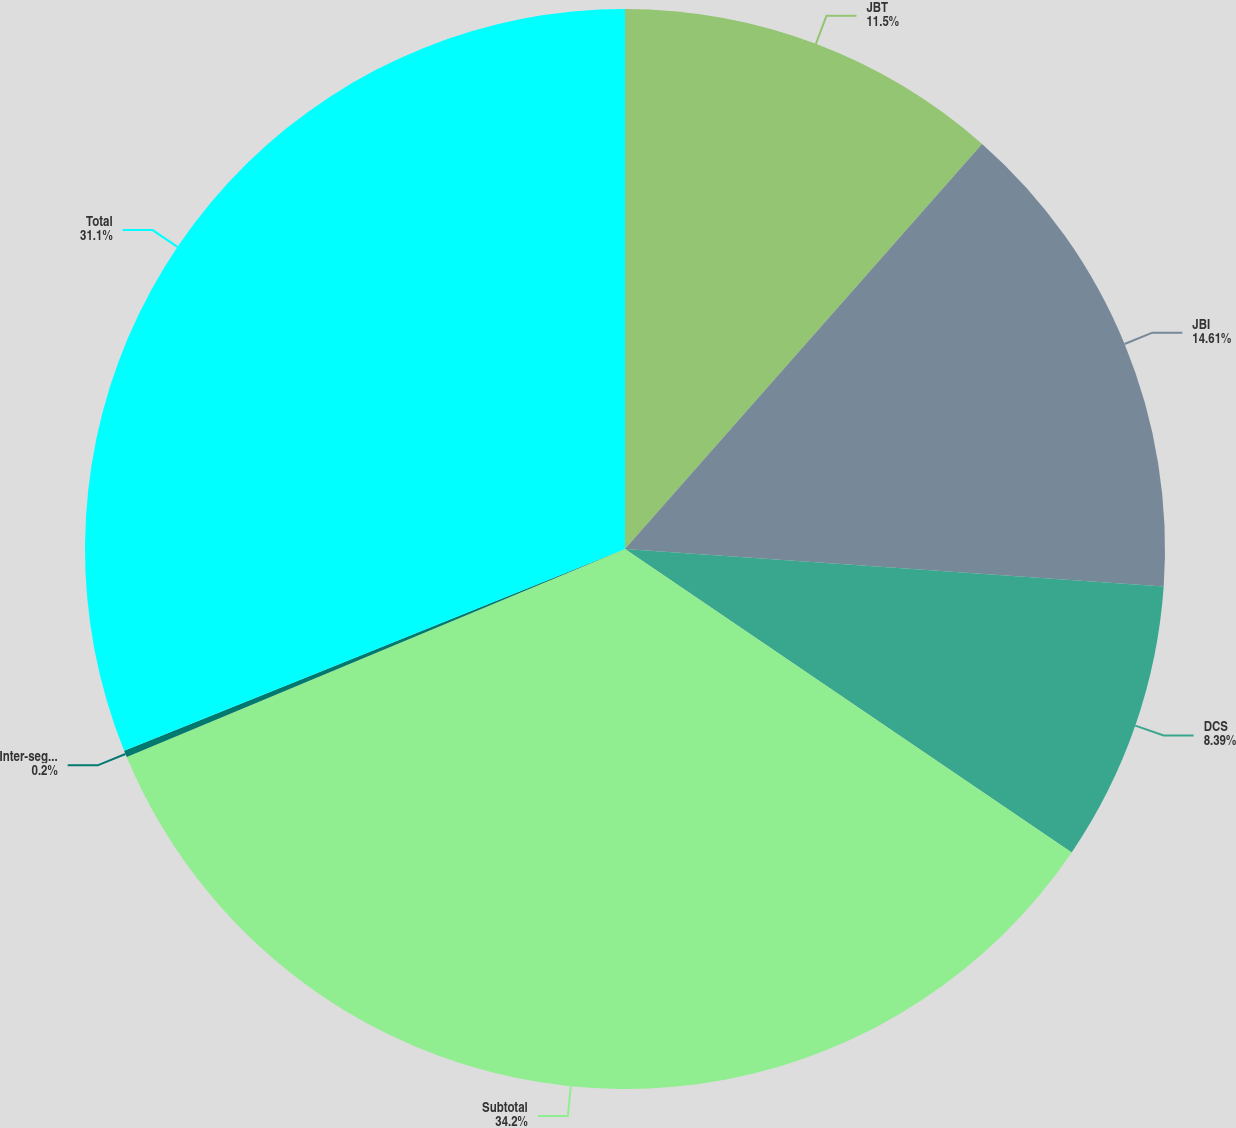Convert chart. <chart><loc_0><loc_0><loc_500><loc_500><pie_chart><fcel>JBT<fcel>JBI<fcel>DCS<fcel>Subtotal<fcel>Inter-segment eliminations<fcel>Total<nl><fcel>11.5%<fcel>14.61%<fcel>8.39%<fcel>34.21%<fcel>0.2%<fcel>31.1%<nl></chart> 